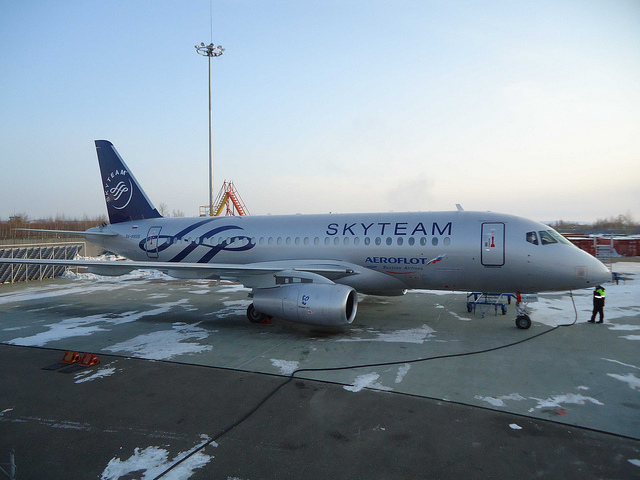Please transcribe the text in this image. SKYTEAM AEROFLOT 